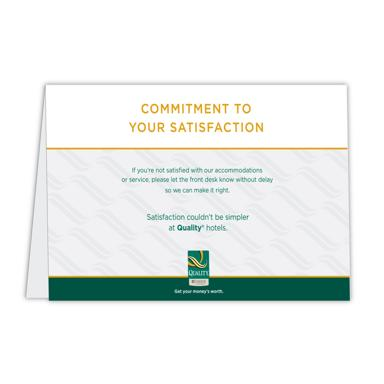What does the text on the business card say regarding customer satisfaction? The business card from Quality Hotels states: 'If you're not satisfied with our accommodations or service, please let the front desk know without delay so we can make it right.' This message underscores the hotel's dedication to ensuring that every guest's stay is exceptional, reflecting a proactive approach in addressing and resolving any issues immediately. 